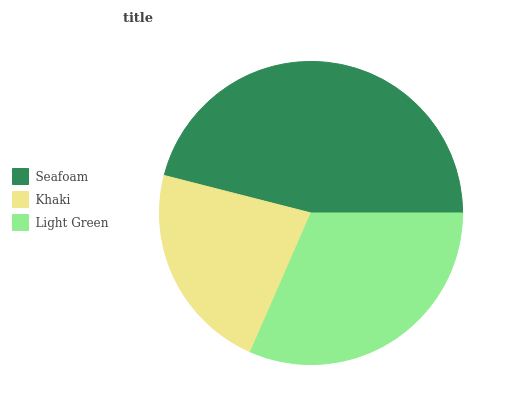Is Khaki the minimum?
Answer yes or no. Yes. Is Seafoam the maximum?
Answer yes or no. Yes. Is Light Green the minimum?
Answer yes or no. No. Is Light Green the maximum?
Answer yes or no. No. Is Light Green greater than Khaki?
Answer yes or no. Yes. Is Khaki less than Light Green?
Answer yes or no. Yes. Is Khaki greater than Light Green?
Answer yes or no. No. Is Light Green less than Khaki?
Answer yes or no. No. Is Light Green the high median?
Answer yes or no. Yes. Is Light Green the low median?
Answer yes or no. Yes. Is Seafoam the high median?
Answer yes or no. No. Is Seafoam the low median?
Answer yes or no. No. 